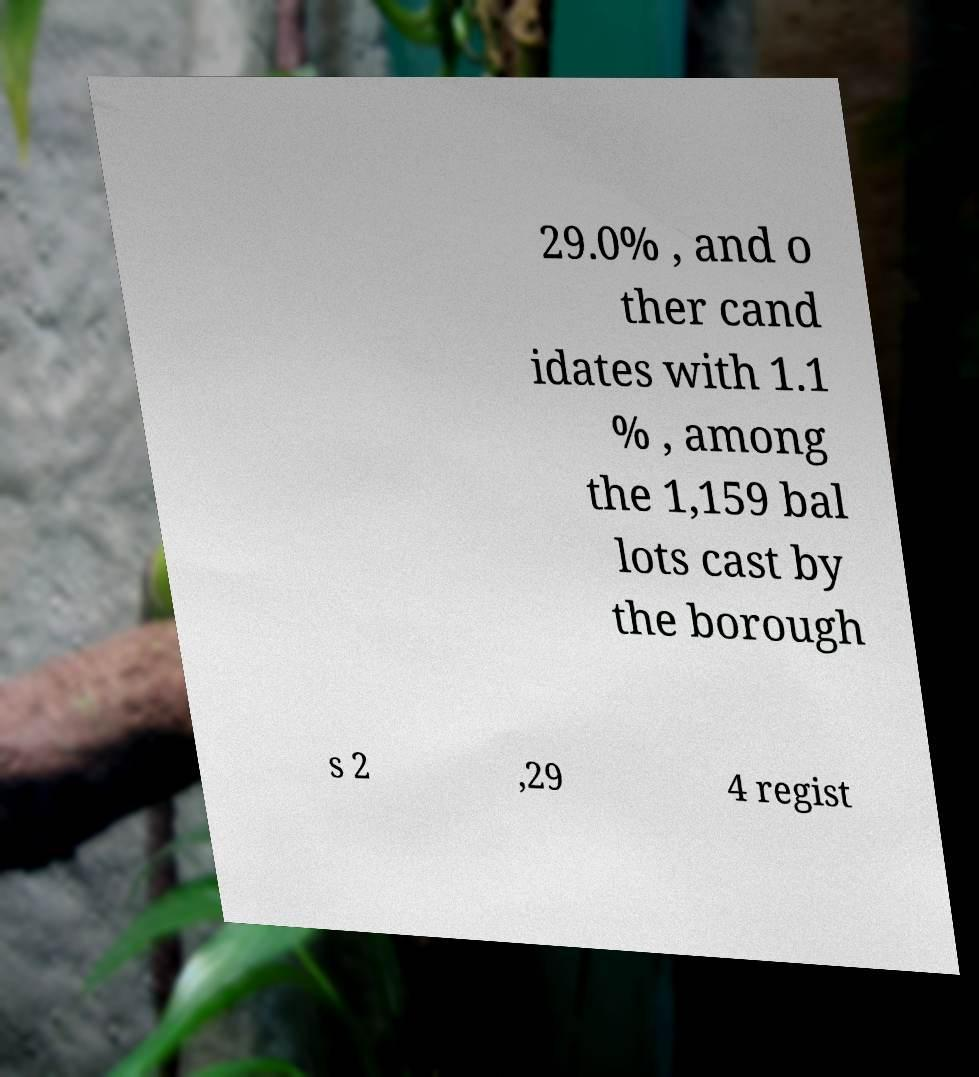Can you accurately transcribe the text from the provided image for me? 29.0% , and o ther cand idates with 1.1 % , among the 1,159 bal lots cast by the borough s 2 ,29 4 regist 